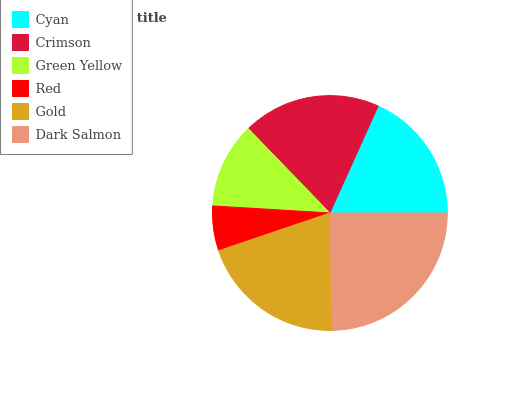Is Red the minimum?
Answer yes or no. Yes. Is Dark Salmon the maximum?
Answer yes or no. Yes. Is Crimson the minimum?
Answer yes or no. No. Is Crimson the maximum?
Answer yes or no. No. Is Crimson greater than Cyan?
Answer yes or no. Yes. Is Cyan less than Crimson?
Answer yes or no. Yes. Is Cyan greater than Crimson?
Answer yes or no. No. Is Crimson less than Cyan?
Answer yes or no. No. Is Crimson the high median?
Answer yes or no. Yes. Is Cyan the low median?
Answer yes or no. Yes. Is Cyan the high median?
Answer yes or no. No. Is Green Yellow the low median?
Answer yes or no. No. 